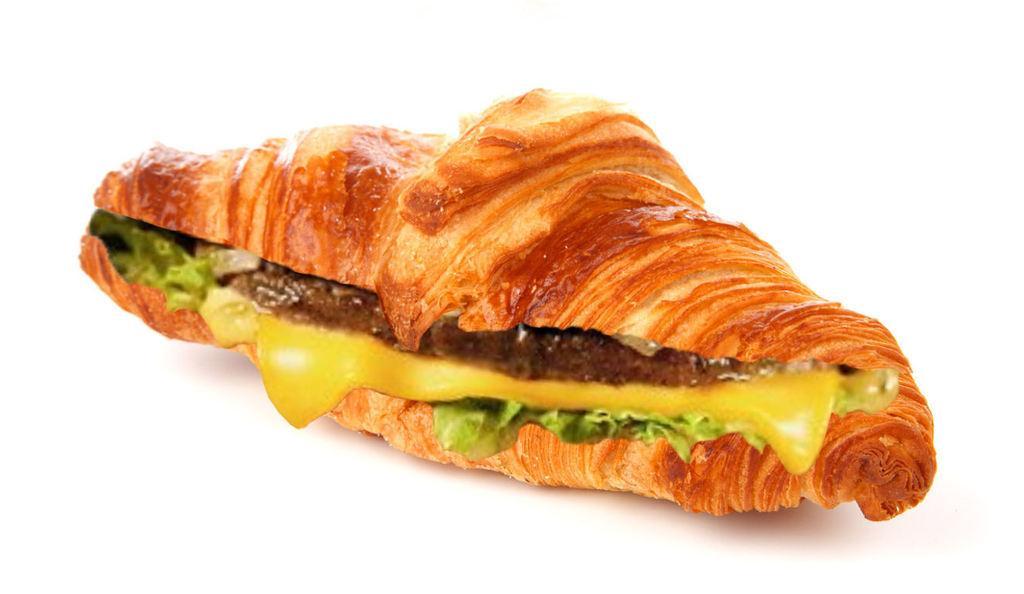In one or two sentences, can you explain what this image depicts? In the middle of this image, there is a food item arranged on a surface. And the background is white in color. 